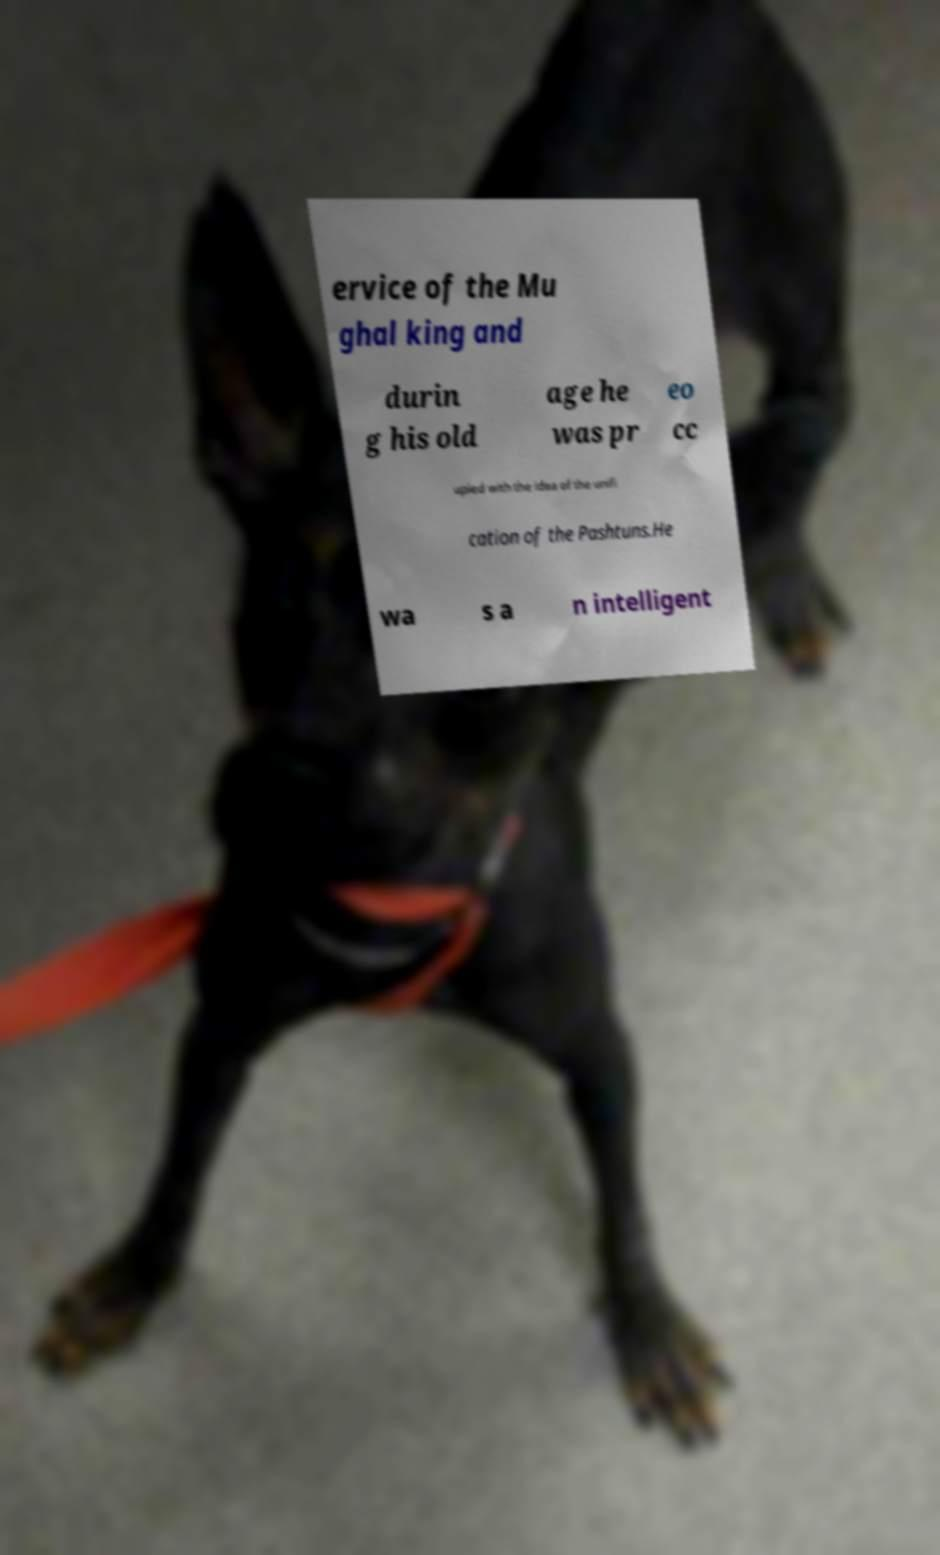Could you extract and type out the text from this image? ervice of the Mu ghal king and durin g his old age he was pr eo cc upied with the idea of the unifi cation of the Pashtuns.He wa s a n intelligent 